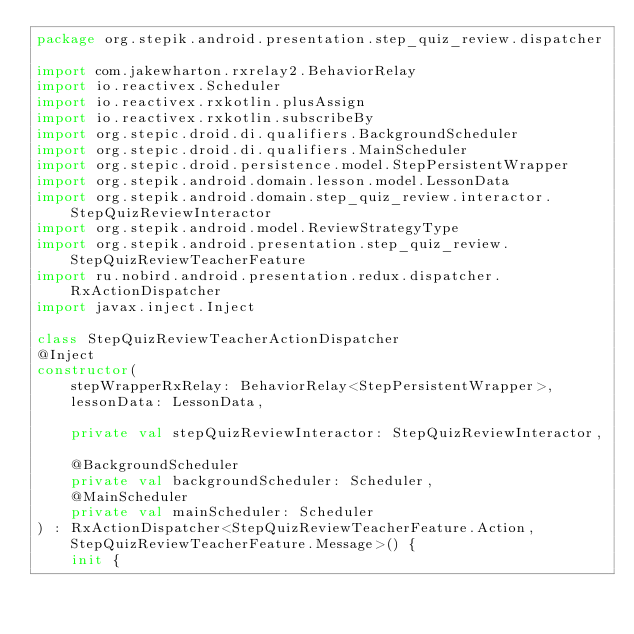<code> <loc_0><loc_0><loc_500><loc_500><_Kotlin_>package org.stepik.android.presentation.step_quiz_review.dispatcher

import com.jakewharton.rxrelay2.BehaviorRelay
import io.reactivex.Scheduler
import io.reactivex.rxkotlin.plusAssign
import io.reactivex.rxkotlin.subscribeBy
import org.stepic.droid.di.qualifiers.BackgroundScheduler
import org.stepic.droid.di.qualifiers.MainScheduler
import org.stepic.droid.persistence.model.StepPersistentWrapper
import org.stepik.android.domain.lesson.model.LessonData
import org.stepik.android.domain.step_quiz_review.interactor.StepQuizReviewInteractor
import org.stepik.android.model.ReviewStrategyType
import org.stepik.android.presentation.step_quiz_review.StepQuizReviewTeacherFeature
import ru.nobird.android.presentation.redux.dispatcher.RxActionDispatcher
import javax.inject.Inject

class StepQuizReviewTeacherActionDispatcher
@Inject
constructor(
    stepWrapperRxRelay: BehaviorRelay<StepPersistentWrapper>,
    lessonData: LessonData,

    private val stepQuizReviewInteractor: StepQuizReviewInteractor,

    @BackgroundScheduler
    private val backgroundScheduler: Scheduler,
    @MainScheduler
    private val mainScheduler: Scheduler
) : RxActionDispatcher<StepQuizReviewTeacherFeature.Action, StepQuizReviewTeacherFeature.Message>() {
    init {</code> 